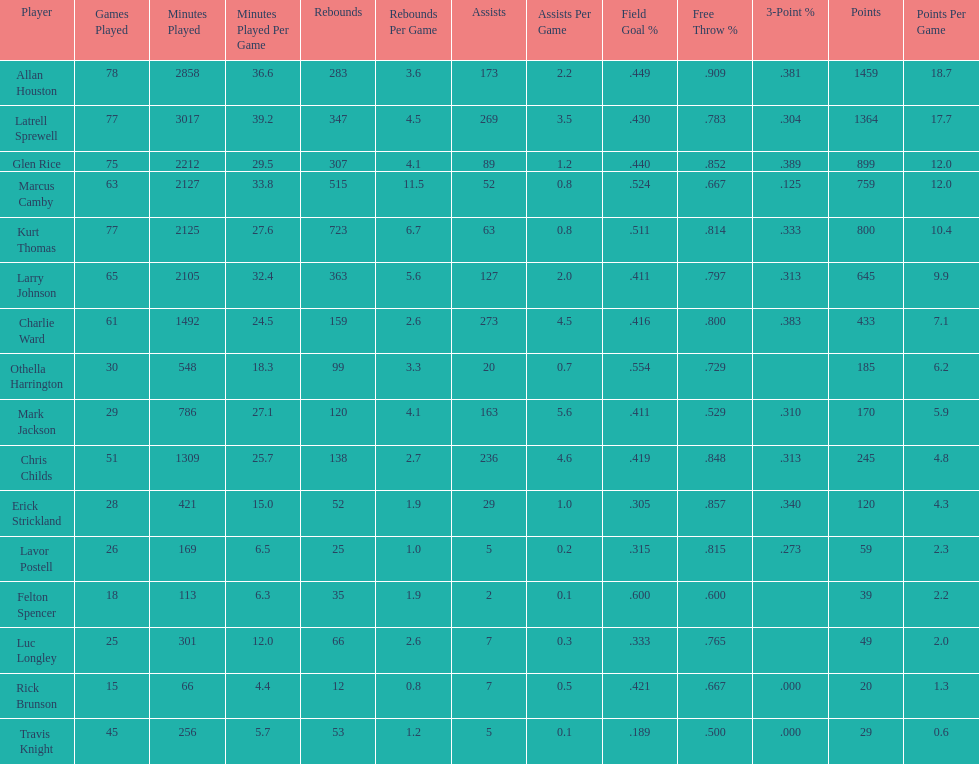Did kurt thomas play more or less than 2126 minutes? Less. 